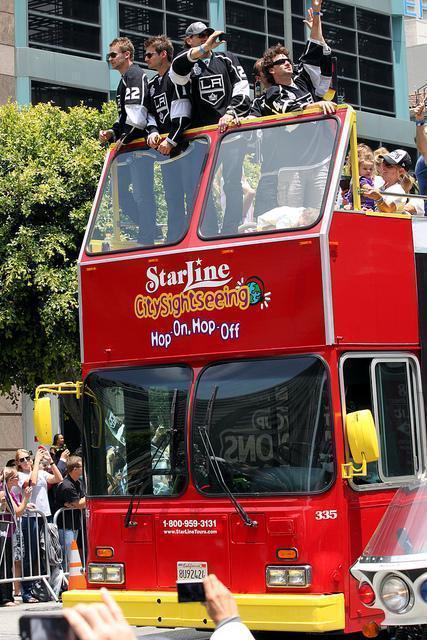The person on the motorcycle escorting the double decker bus is what type of public servant?
Indicate the correct response by choosing from the four available options to answer the question.
Options: Fireman, soldier, policeman, inspector. Policeman. 